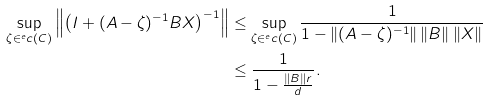Convert formula to latex. <formula><loc_0><loc_0><loc_500><loc_500>\sup _ { \zeta \in ^ { e } c ( C ) } \left \| \left ( I + ( A - \zeta ) ^ { - 1 } B X \right ) ^ { - 1 } \right \| & \leq \sup _ { \zeta \in ^ { e } c ( C ) } \frac { 1 } { 1 - \| ( A - \zeta ) ^ { - 1 } \| \, \| B \| \, \| X \| } \\ & \leq \frac { 1 } { 1 - \frac { \| B \| r } { d } } .</formula> 